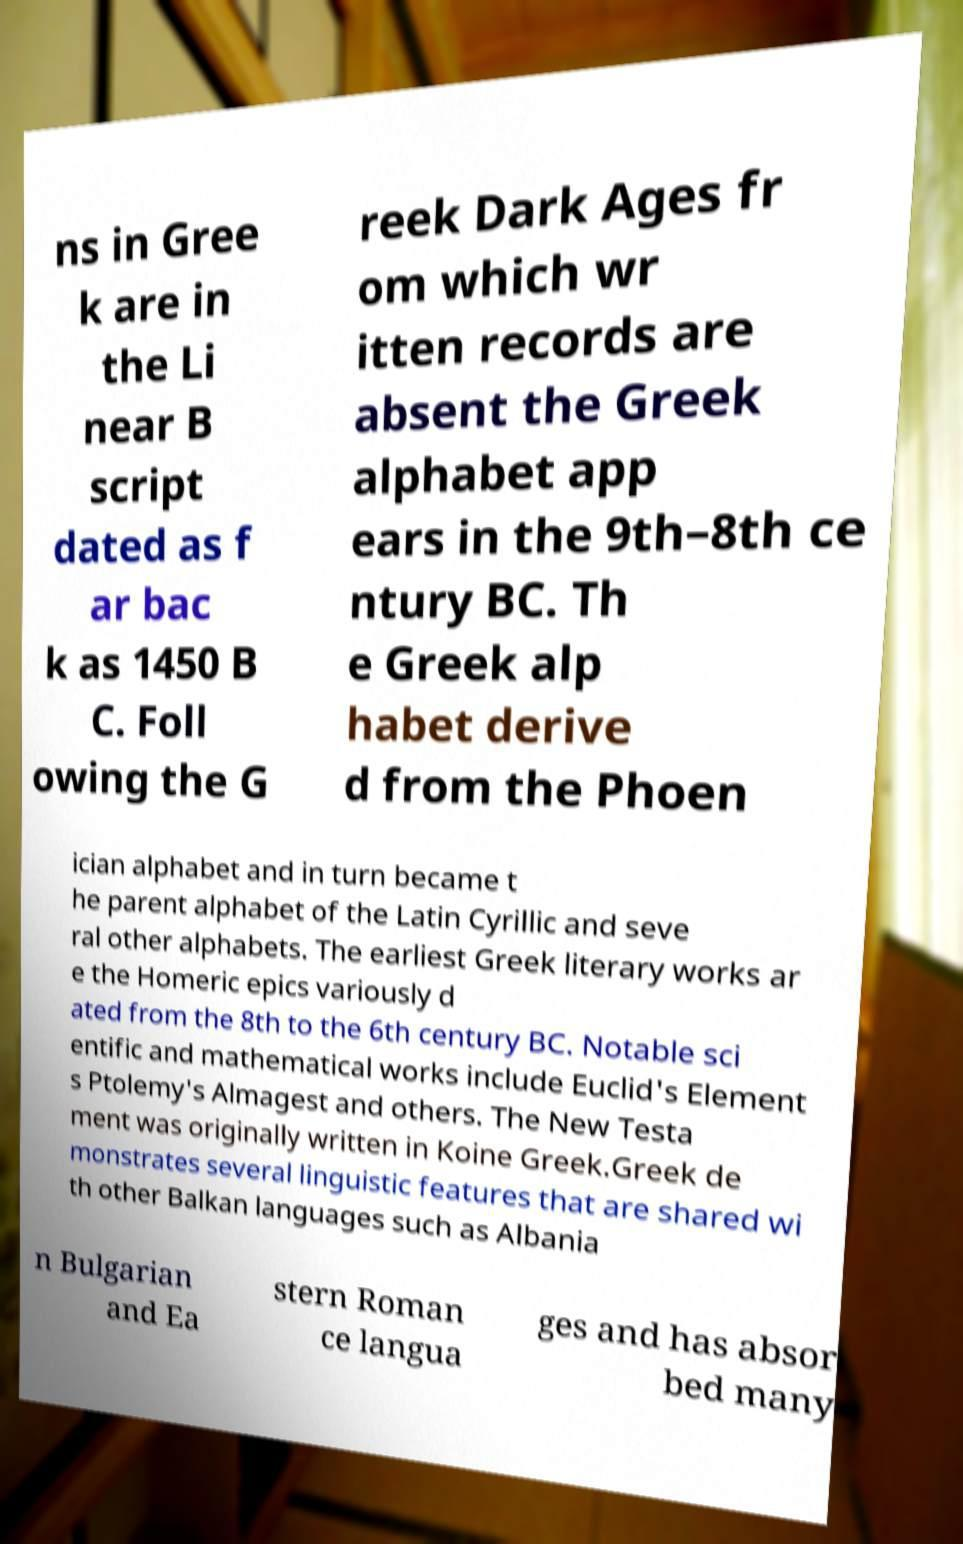For documentation purposes, I need the text within this image transcribed. Could you provide that? ns in Gree k are in the Li near B script dated as f ar bac k as 1450 B C. Foll owing the G reek Dark Ages fr om which wr itten records are absent the Greek alphabet app ears in the 9th–8th ce ntury BC. Th e Greek alp habet derive d from the Phoen ician alphabet and in turn became t he parent alphabet of the Latin Cyrillic and seve ral other alphabets. The earliest Greek literary works ar e the Homeric epics variously d ated from the 8th to the 6th century BC. Notable sci entific and mathematical works include Euclid's Element s Ptolemy's Almagest and others. The New Testa ment was originally written in Koine Greek.Greek de monstrates several linguistic features that are shared wi th other Balkan languages such as Albania n Bulgarian and Ea stern Roman ce langua ges and has absor bed many 